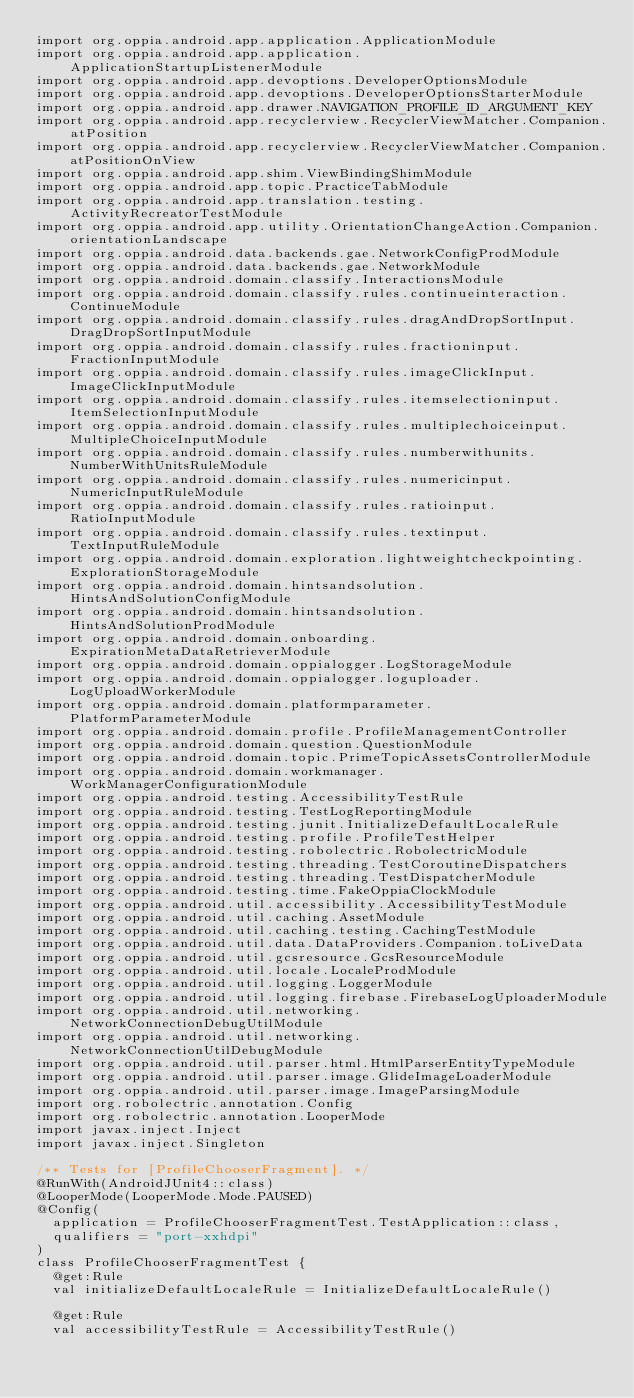Convert code to text. <code><loc_0><loc_0><loc_500><loc_500><_Kotlin_>import org.oppia.android.app.application.ApplicationModule
import org.oppia.android.app.application.ApplicationStartupListenerModule
import org.oppia.android.app.devoptions.DeveloperOptionsModule
import org.oppia.android.app.devoptions.DeveloperOptionsStarterModule
import org.oppia.android.app.drawer.NAVIGATION_PROFILE_ID_ARGUMENT_KEY
import org.oppia.android.app.recyclerview.RecyclerViewMatcher.Companion.atPosition
import org.oppia.android.app.recyclerview.RecyclerViewMatcher.Companion.atPositionOnView
import org.oppia.android.app.shim.ViewBindingShimModule
import org.oppia.android.app.topic.PracticeTabModule
import org.oppia.android.app.translation.testing.ActivityRecreatorTestModule
import org.oppia.android.app.utility.OrientationChangeAction.Companion.orientationLandscape
import org.oppia.android.data.backends.gae.NetworkConfigProdModule
import org.oppia.android.data.backends.gae.NetworkModule
import org.oppia.android.domain.classify.InteractionsModule
import org.oppia.android.domain.classify.rules.continueinteraction.ContinueModule
import org.oppia.android.domain.classify.rules.dragAndDropSortInput.DragDropSortInputModule
import org.oppia.android.domain.classify.rules.fractioninput.FractionInputModule
import org.oppia.android.domain.classify.rules.imageClickInput.ImageClickInputModule
import org.oppia.android.domain.classify.rules.itemselectioninput.ItemSelectionInputModule
import org.oppia.android.domain.classify.rules.multiplechoiceinput.MultipleChoiceInputModule
import org.oppia.android.domain.classify.rules.numberwithunits.NumberWithUnitsRuleModule
import org.oppia.android.domain.classify.rules.numericinput.NumericInputRuleModule
import org.oppia.android.domain.classify.rules.ratioinput.RatioInputModule
import org.oppia.android.domain.classify.rules.textinput.TextInputRuleModule
import org.oppia.android.domain.exploration.lightweightcheckpointing.ExplorationStorageModule
import org.oppia.android.domain.hintsandsolution.HintsAndSolutionConfigModule
import org.oppia.android.domain.hintsandsolution.HintsAndSolutionProdModule
import org.oppia.android.domain.onboarding.ExpirationMetaDataRetrieverModule
import org.oppia.android.domain.oppialogger.LogStorageModule
import org.oppia.android.domain.oppialogger.loguploader.LogUploadWorkerModule
import org.oppia.android.domain.platformparameter.PlatformParameterModule
import org.oppia.android.domain.profile.ProfileManagementController
import org.oppia.android.domain.question.QuestionModule
import org.oppia.android.domain.topic.PrimeTopicAssetsControllerModule
import org.oppia.android.domain.workmanager.WorkManagerConfigurationModule
import org.oppia.android.testing.AccessibilityTestRule
import org.oppia.android.testing.TestLogReportingModule
import org.oppia.android.testing.junit.InitializeDefaultLocaleRule
import org.oppia.android.testing.profile.ProfileTestHelper
import org.oppia.android.testing.robolectric.RobolectricModule
import org.oppia.android.testing.threading.TestCoroutineDispatchers
import org.oppia.android.testing.threading.TestDispatcherModule
import org.oppia.android.testing.time.FakeOppiaClockModule
import org.oppia.android.util.accessibility.AccessibilityTestModule
import org.oppia.android.util.caching.AssetModule
import org.oppia.android.util.caching.testing.CachingTestModule
import org.oppia.android.util.data.DataProviders.Companion.toLiveData
import org.oppia.android.util.gcsresource.GcsResourceModule
import org.oppia.android.util.locale.LocaleProdModule
import org.oppia.android.util.logging.LoggerModule
import org.oppia.android.util.logging.firebase.FirebaseLogUploaderModule
import org.oppia.android.util.networking.NetworkConnectionDebugUtilModule
import org.oppia.android.util.networking.NetworkConnectionUtilDebugModule
import org.oppia.android.util.parser.html.HtmlParserEntityTypeModule
import org.oppia.android.util.parser.image.GlideImageLoaderModule
import org.oppia.android.util.parser.image.ImageParsingModule
import org.robolectric.annotation.Config
import org.robolectric.annotation.LooperMode
import javax.inject.Inject
import javax.inject.Singleton

/** Tests for [ProfileChooserFragment]. */
@RunWith(AndroidJUnit4::class)
@LooperMode(LooperMode.Mode.PAUSED)
@Config(
  application = ProfileChooserFragmentTest.TestApplication::class,
  qualifiers = "port-xxhdpi"
)
class ProfileChooserFragmentTest {
  @get:Rule
  val initializeDefaultLocaleRule = InitializeDefaultLocaleRule()

  @get:Rule
  val accessibilityTestRule = AccessibilityTestRule()
</code> 